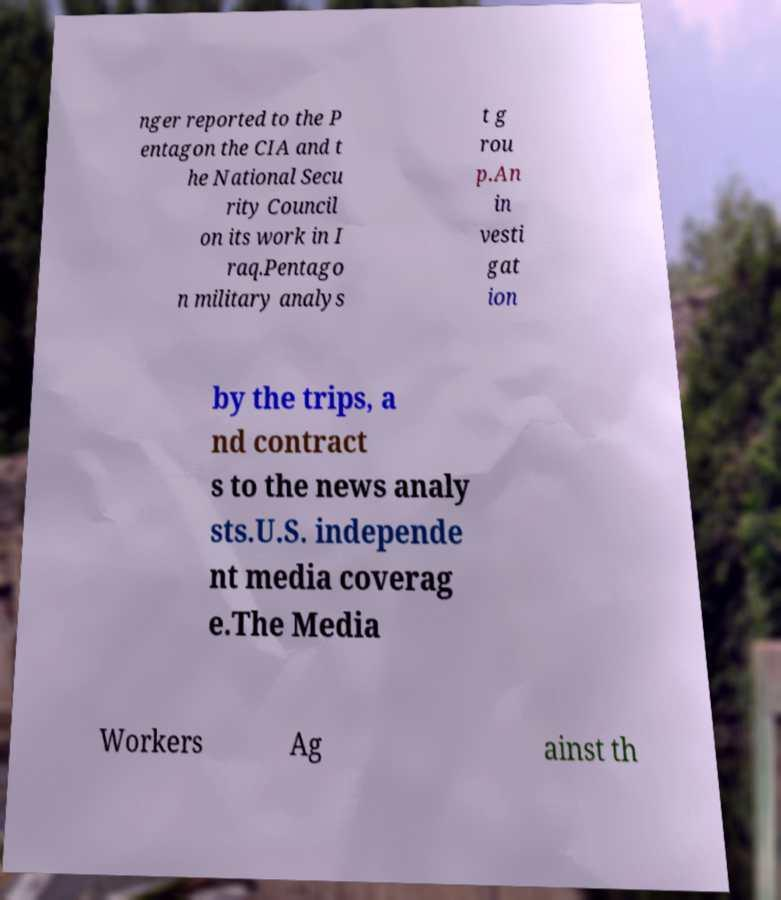For documentation purposes, I need the text within this image transcribed. Could you provide that? nger reported to the P entagon the CIA and t he National Secu rity Council on its work in I raq.Pentago n military analys t g rou p.An in vesti gat ion by the trips, a nd contract s to the news analy sts.U.S. independe nt media coverag e.The Media Workers Ag ainst th 